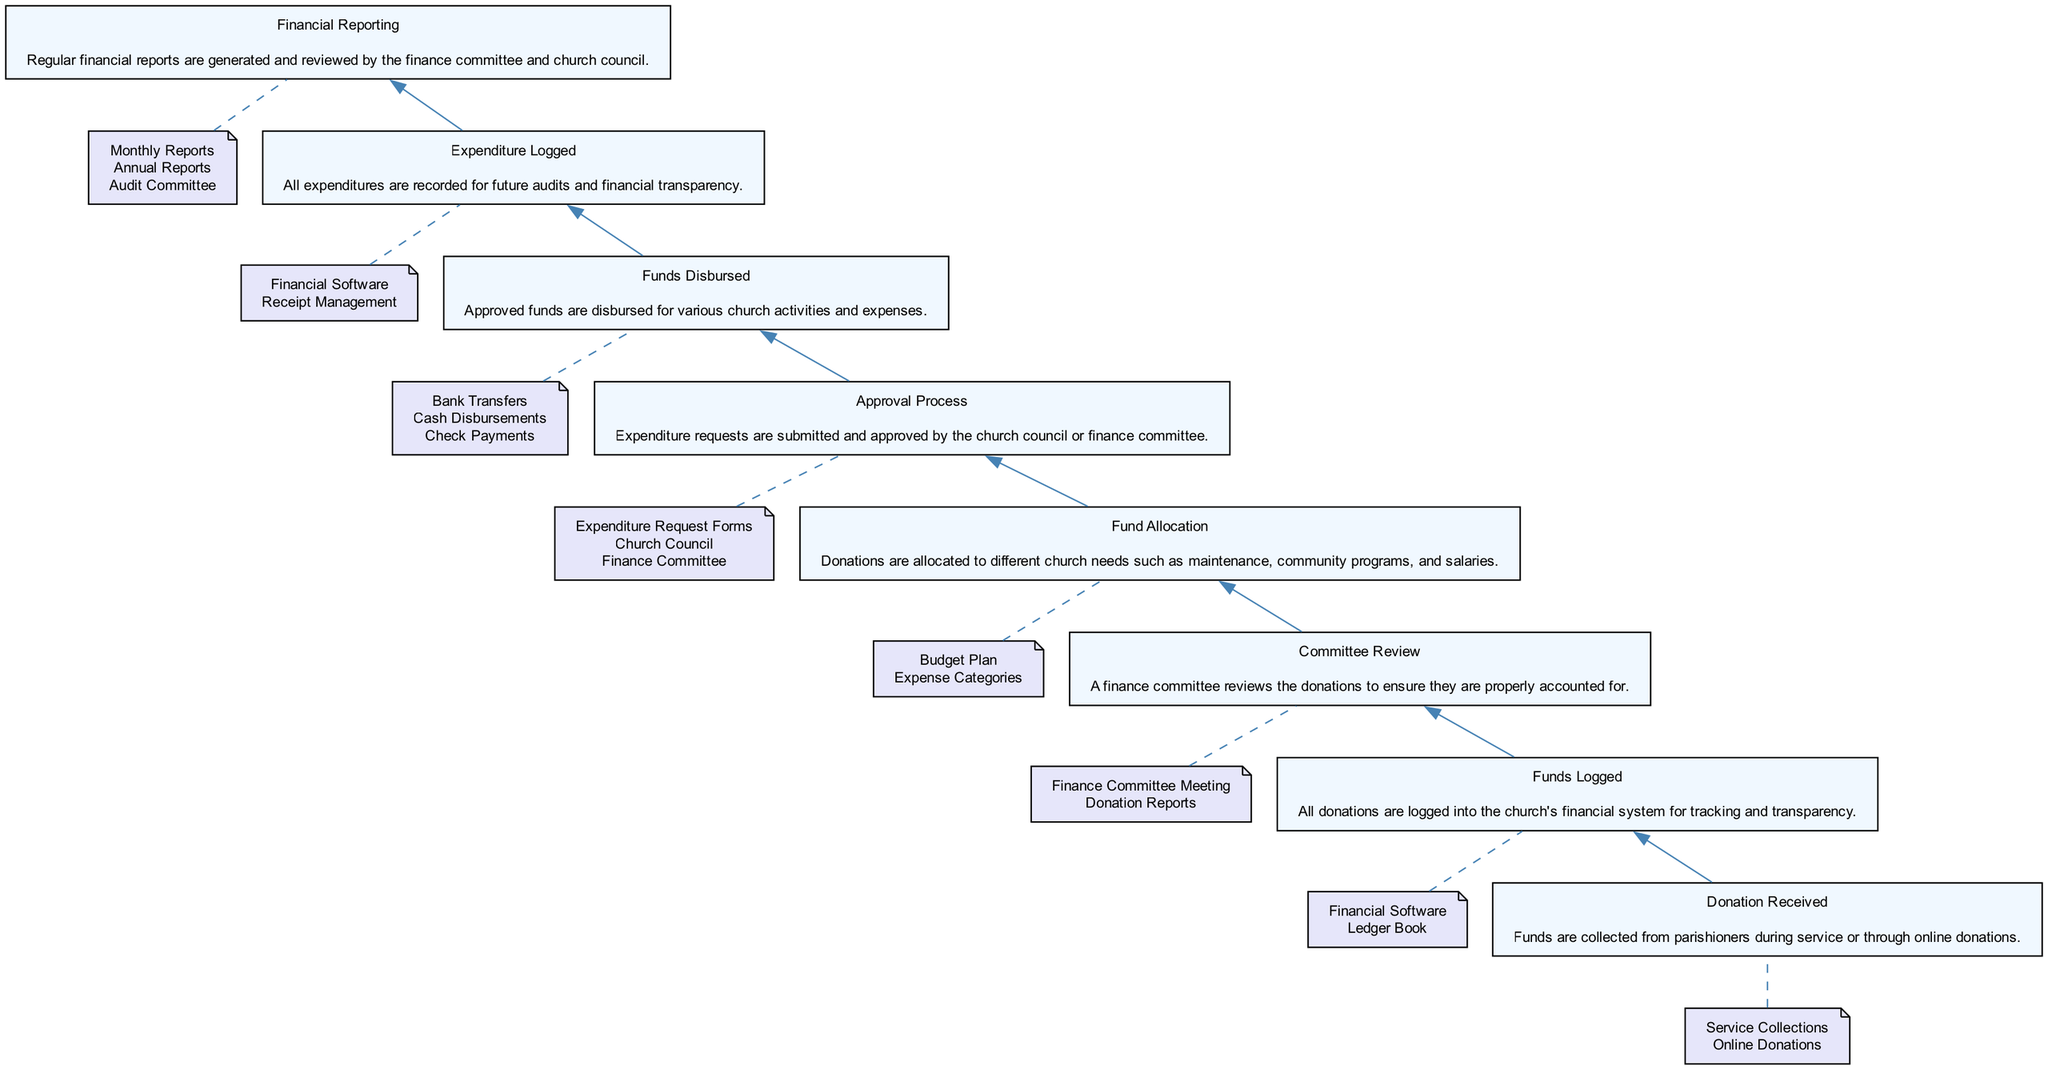What is the first step in managing church finances? The first step is "Donation Received." This indicates that the process begins with the collection of funds from parishioners.
Answer: Donation Received How many total steps are in the process? There are eight steps in total as listed from "Donation Received" to "Financial Reporting" following the flow from bottom to up.
Answer: 8 Which node comes immediately after "Committee Review"? The node that comes immediately after "Committee Review" is "Fund Allocation." This indicates the next phase after the review of donations.
Answer: Fund Allocation What are the entities involved in the "Funds Logged" step? The entities involved in the "Funds Logged" step are "Financial Software" and "Ledger Book," which are used to manage the logging of the donations.
Answer: Financial Software, Ledger Book What is the purpose of the "Expenditure Logged" step? The purpose of the "Expenditure Logged" step is to record all expenditures for future audits and ensure financial transparency following the distribution of funds.
Answer: Financial transparency What is the relationship between "Funds Disbursed" and "Approval Process"? "Funds Disbursed" follows "Approval Process," indicating that funds can only be disbursed after receiving the necessary approvals for expenditure requests.
Answer: Sequential relationship Which step directly leads to "Financial Reporting"? The step that directly leads to "Financial Reporting" is "Expenditure Logged," suggesting that recording expenditures is essential before generating financial reports.
Answer: Expenditure Logged How does the "Committee Review" ensure donations are accounted for? "Committee Review" ensures donations are accounted for through meetings and examination of donation reports to verify proper accounting practices.
Answer: Verification of donations What is entailed in the "Funds Disbursed" step? The "Funds Disbursed" step entails the process of allocating approved funds for activities and expenses through different payment methods.
Answer: Allocation of funds 